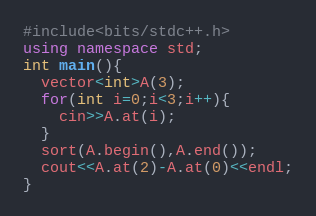Convert code to text. <code><loc_0><loc_0><loc_500><loc_500><_C++_>#include<bits/stdc++.h>
using namespace std;
int main(){
  vector<int>A(3);
  for(int i=0;i<3;i++){
    cin>>A.at(i);
  }
  sort(A.begin(),A.end());
  cout<<A.at(2)-A.at(0)<<endl;
}
</code> 